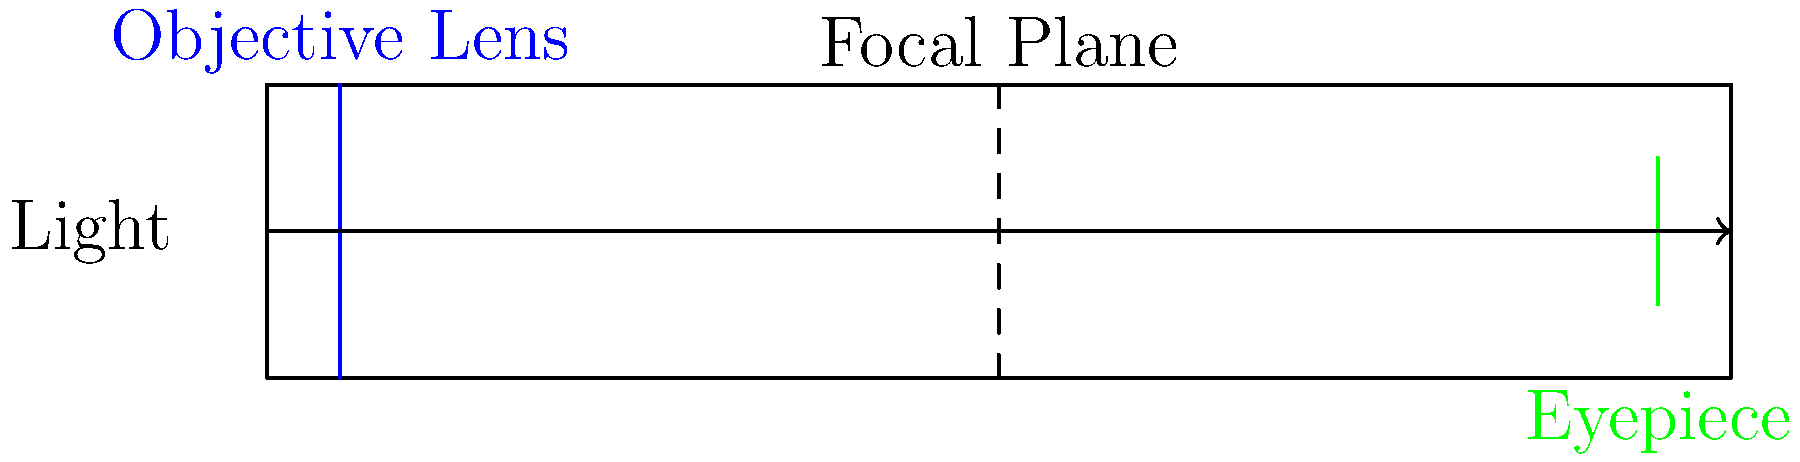In the schematic of a refracting telescope shown above, what is the primary function of the component labeled "Objective Lens"? To understand the function of the objective lens in a refracting telescope, let's break down the components and their roles:

1. Light enters the telescope from the left side of the diagram.

2. The first component the light encounters is the objective lens (blue line).

3. The objective lens is responsible for:
   a. Collecting light from distant objects
   b. Focusing this light to form an image

4. The focused light converges at the focal plane (dashed line in the middle).

5. The eyepiece (green line) then magnifies this image for viewing.

The primary function of the objective lens is to gather as much light as possible from distant objects and focus it to form an image. The larger the objective lens, the more light it can collect, allowing for observation of fainter objects.

In the context of .NET development and COM interop, you can think of the objective lens as analogous to an API or interface that collects and focuses data from external sources before it's processed further by other components of your system.
Answer: Collect and focus light from distant objects 